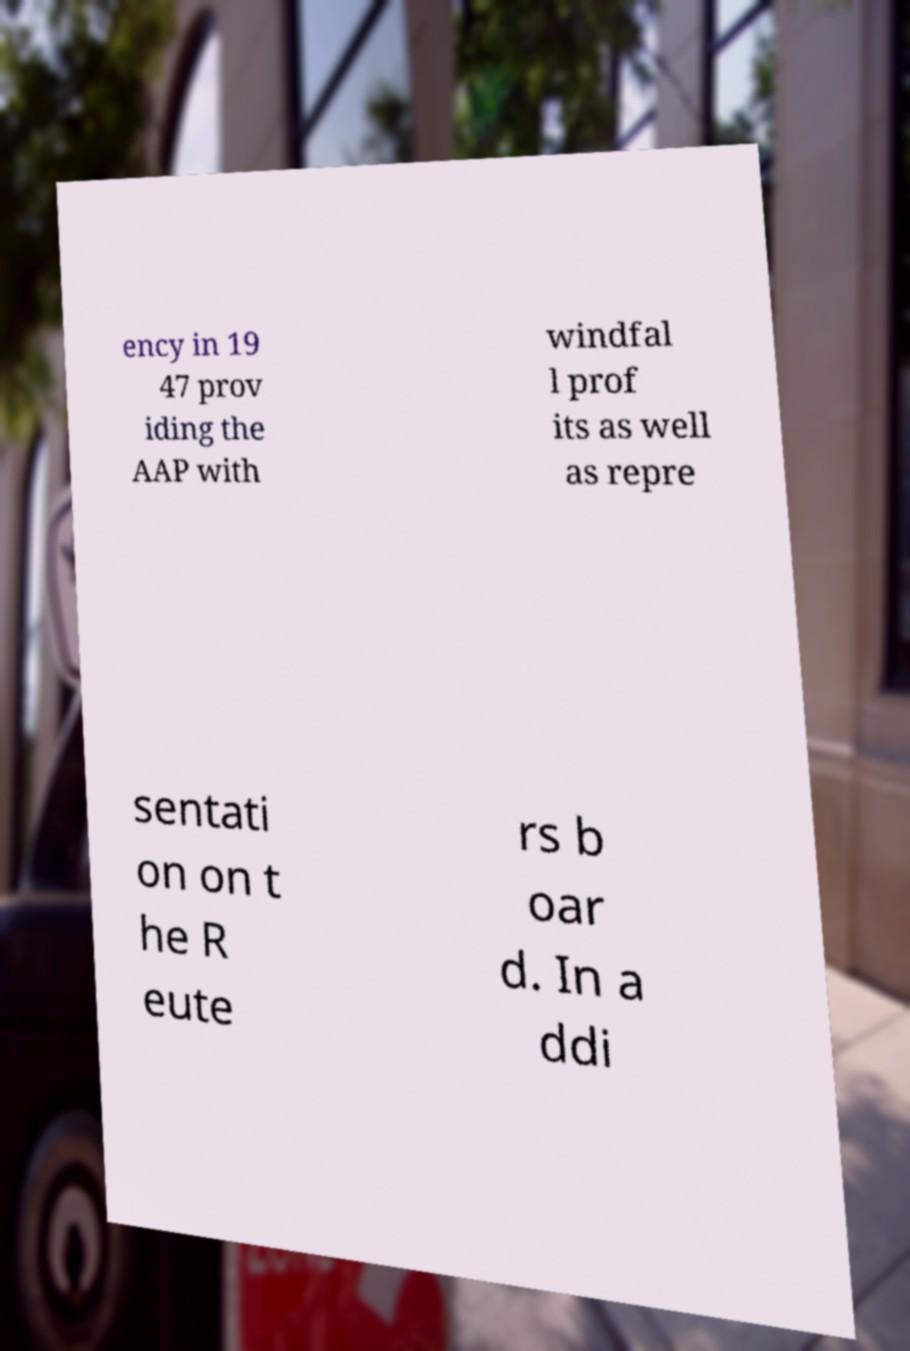There's text embedded in this image that I need extracted. Can you transcribe it verbatim? ency in 19 47 prov iding the AAP with windfal l prof its as well as repre sentati on on t he R eute rs b oar d. In a ddi 